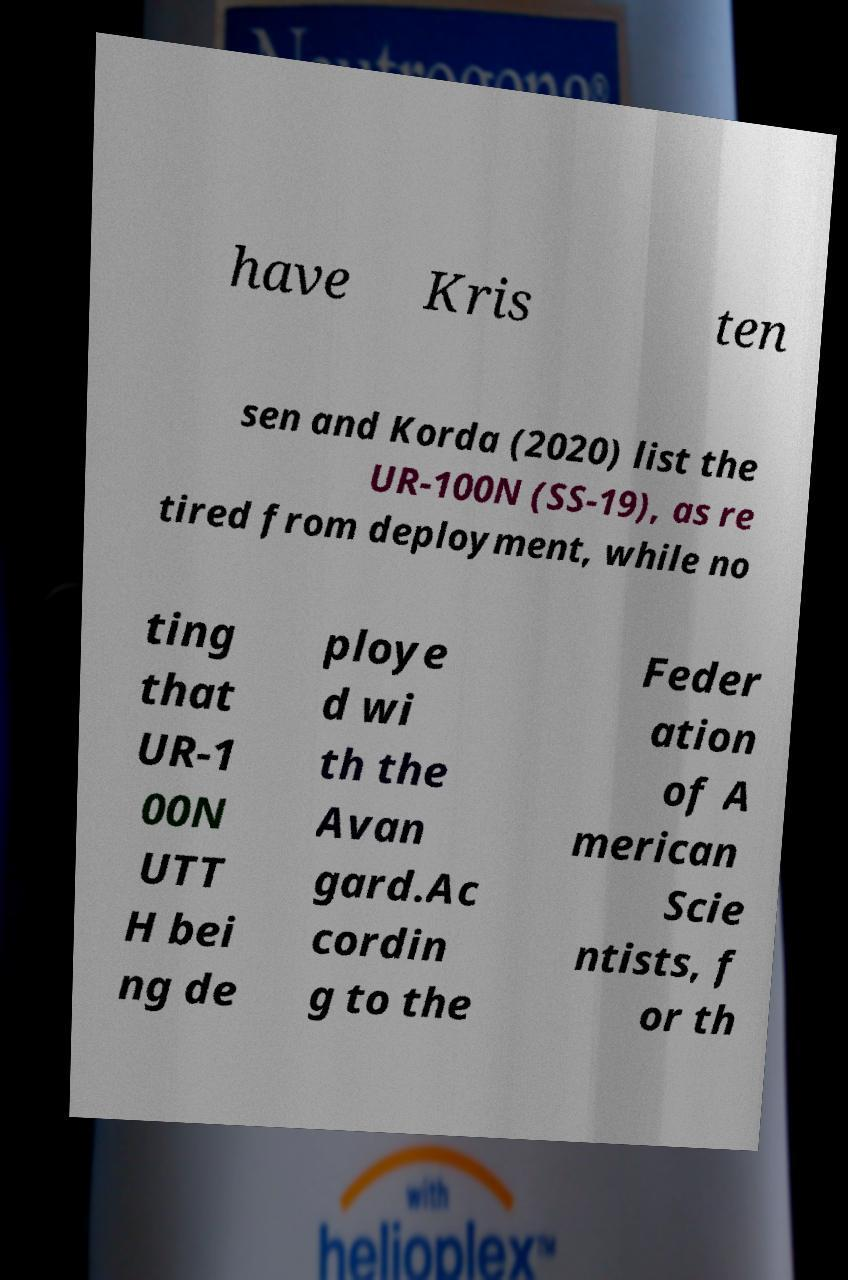There's text embedded in this image that I need extracted. Can you transcribe it verbatim? have Kris ten sen and Korda (2020) list the UR-100N (SS-19), as re tired from deployment, while no ting that UR-1 00N UTT H bei ng de ploye d wi th the Avan gard.Ac cordin g to the Feder ation of A merican Scie ntists, f or th 